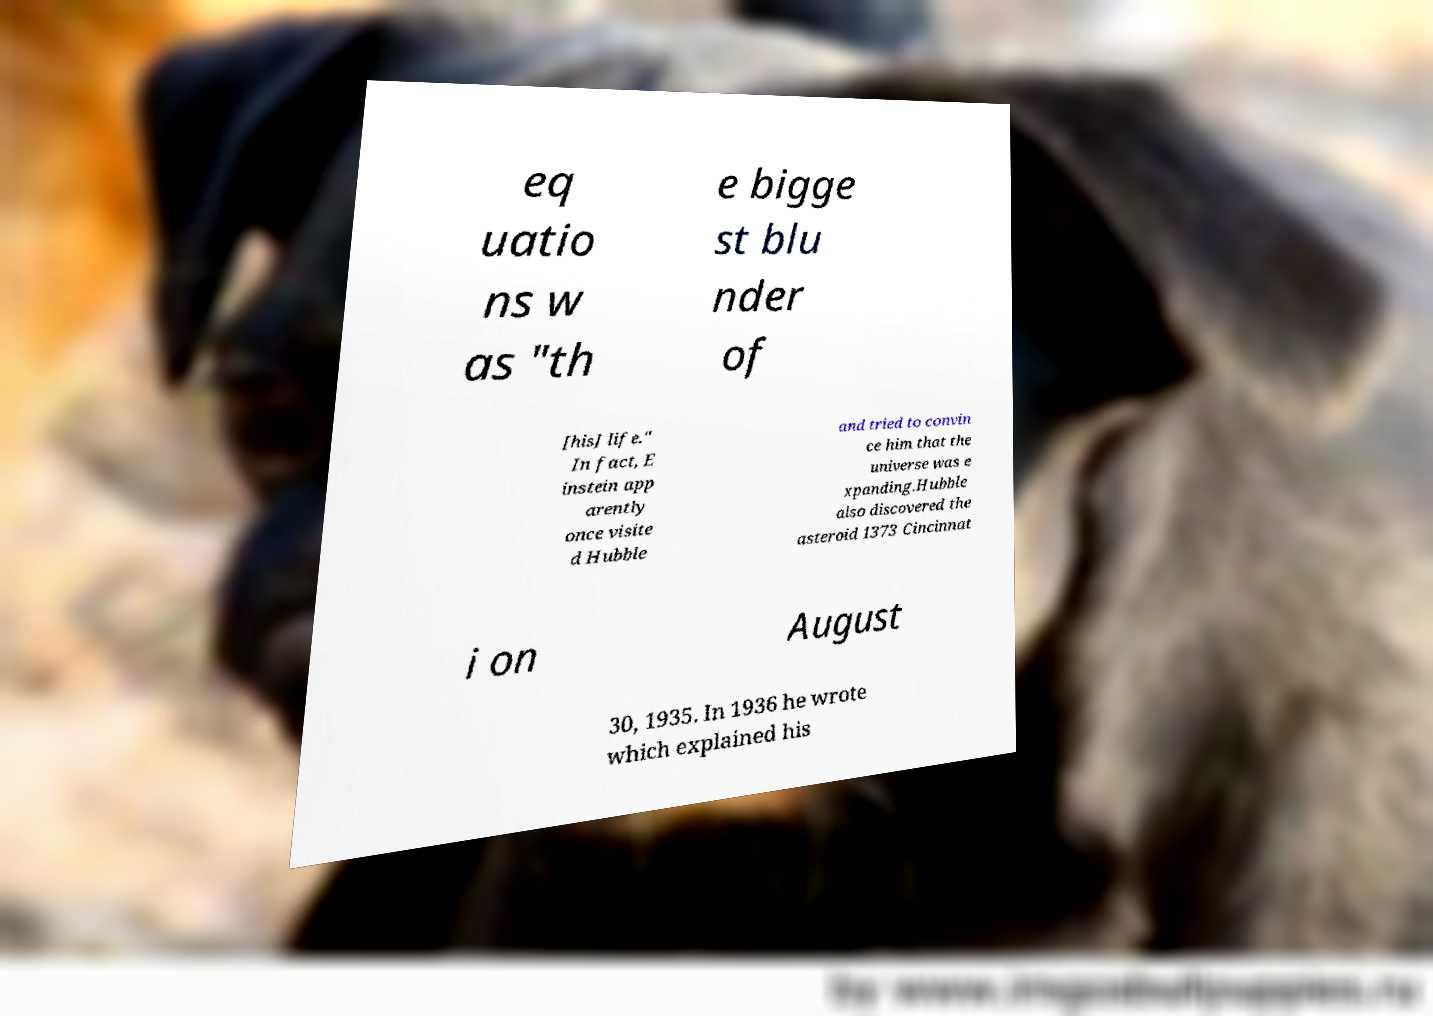Can you read and provide the text displayed in the image?This photo seems to have some interesting text. Can you extract and type it out for me? eq uatio ns w as "th e bigge st blu nder of [his] life." In fact, E instein app arently once visite d Hubble and tried to convin ce him that the universe was e xpanding.Hubble also discovered the asteroid 1373 Cincinnat i on August 30, 1935. In 1936 he wrote which explained his 